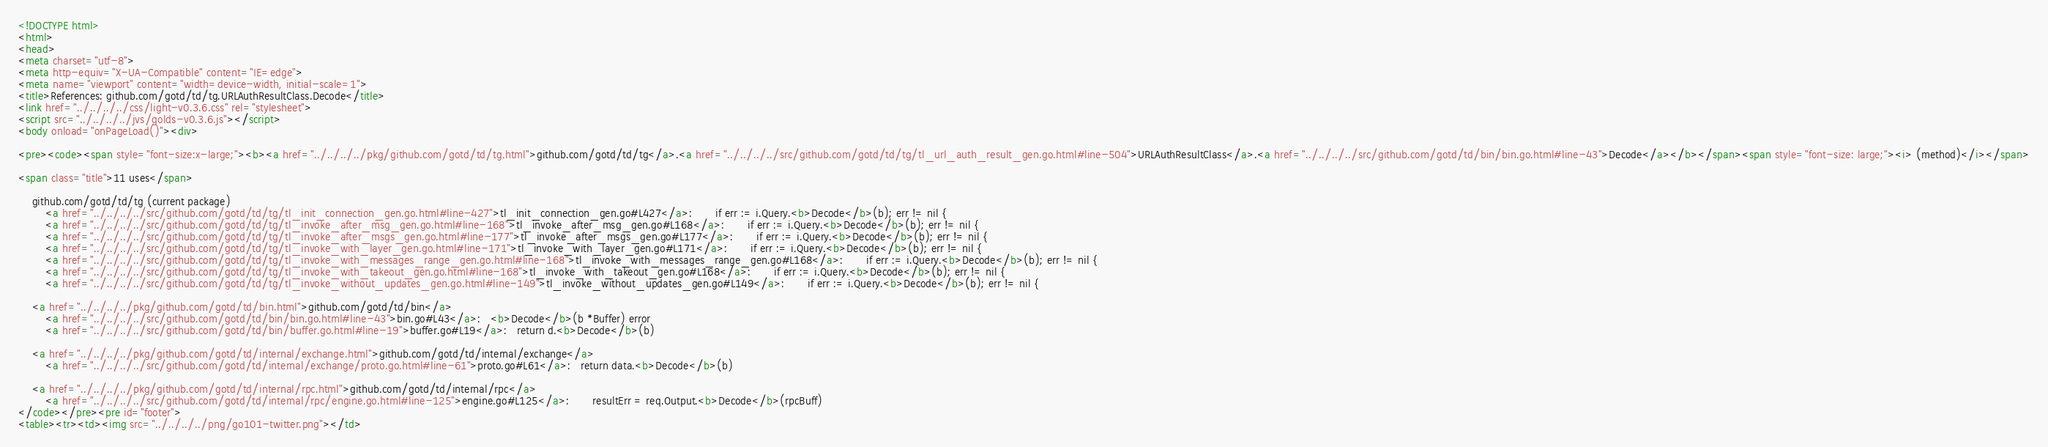<code> <loc_0><loc_0><loc_500><loc_500><_HTML_><!DOCTYPE html>
<html>
<head>
<meta charset="utf-8">
<meta http-equiv="X-UA-Compatible" content="IE=edge">
<meta name="viewport" content="width=device-width, initial-scale=1">
<title>References: github.com/gotd/td/tg.URLAuthResultClass.Decode</title>
<link href="../../../../css/light-v0.3.6.css" rel="stylesheet">
<script src="../../../../jvs/golds-v0.3.6.js"></script>
<body onload="onPageLoad()"><div>

<pre><code><span style="font-size:x-large;"><b><a href="../../../../pkg/github.com/gotd/td/tg.html">github.com/gotd/td/tg</a>.<a href="../../../../src/github.com/gotd/td/tg/tl_url_auth_result_gen.go.html#line-504">URLAuthResultClass</a>.<a href="../../../../src/github.com/gotd/td/bin/bin.go.html#line-43">Decode</a></b></span><span style="font-size: large;"><i> (method)</i></span>

<span class="title">11 uses</span>

	github.com/gotd/td/tg (current package)
		<a href="../../../../src/github.com/gotd/td/tg/tl_init_connection_gen.go.html#line-427">tl_init_connection_gen.go#L427</a>: 		if err := i.Query.<b>Decode</b>(b); err != nil {
		<a href="../../../../src/github.com/gotd/td/tg/tl_invoke_after_msg_gen.go.html#line-168">tl_invoke_after_msg_gen.go#L168</a>: 		if err := i.Query.<b>Decode</b>(b); err != nil {
		<a href="../../../../src/github.com/gotd/td/tg/tl_invoke_after_msgs_gen.go.html#line-177">tl_invoke_after_msgs_gen.go#L177</a>: 		if err := i.Query.<b>Decode</b>(b); err != nil {
		<a href="../../../../src/github.com/gotd/td/tg/tl_invoke_with_layer_gen.go.html#line-171">tl_invoke_with_layer_gen.go#L171</a>: 		if err := i.Query.<b>Decode</b>(b); err != nil {
		<a href="../../../../src/github.com/gotd/td/tg/tl_invoke_with_messages_range_gen.go.html#line-168">tl_invoke_with_messages_range_gen.go#L168</a>: 		if err := i.Query.<b>Decode</b>(b); err != nil {
		<a href="../../../../src/github.com/gotd/td/tg/tl_invoke_with_takeout_gen.go.html#line-168">tl_invoke_with_takeout_gen.go#L168</a>: 		if err := i.Query.<b>Decode</b>(b); err != nil {
		<a href="../../../../src/github.com/gotd/td/tg/tl_invoke_without_updates_gen.go.html#line-149">tl_invoke_without_updates_gen.go#L149</a>: 		if err := i.Query.<b>Decode</b>(b); err != nil {

	<a href="../../../../pkg/github.com/gotd/td/bin.html">github.com/gotd/td/bin</a>
		<a href="../../../../src/github.com/gotd/td/bin/bin.go.html#line-43">bin.go#L43</a>: 	<b>Decode</b>(b *Buffer) error
		<a href="../../../../src/github.com/gotd/td/bin/buffer.go.html#line-19">buffer.go#L19</a>: 	return d.<b>Decode</b>(b)

	<a href="../../../../pkg/github.com/gotd/td/internal/exchange.html">github.com/gotd/td/internal/exchange</a>
		<a href="../../../../src/github.com/gotd/td/internal/exchange/proto.go.html#line-61">proto.go#L61</a>: 	return data.<b>Decode</b>(b)

	<a href="../../../../pkg/github.com/gotd/td/internal/rpc.html">github.com/gotd/td/internal/rpc</a>
		<a href="../../../../src/github.com/gotd/td/internal/rpc/engine.go.html#line-125">engine.go#L125</a>: 		resultErr = req.Output.<b>Decode</b>(rpcBuff)
</code></pre><pre id="footer">
<table><tr><td><img src="../../../../png/go101-twitter.png"></td></code> 